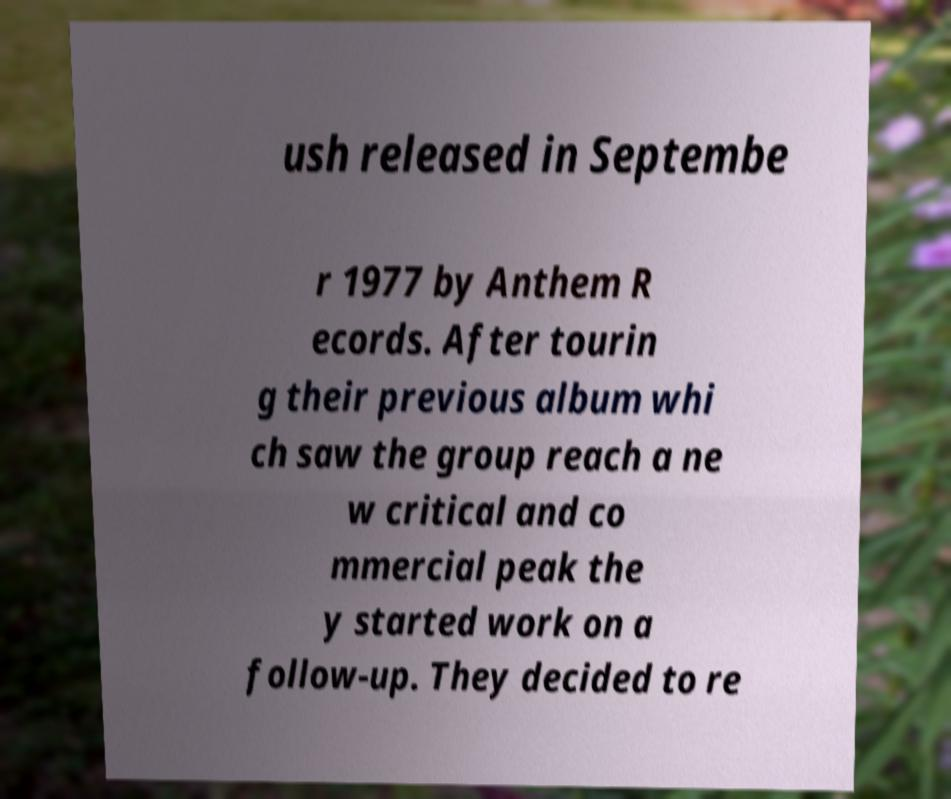Please read and relay the text visible in this image. What does it say? ush released in Septembe r 1977 by Anthem R ecords. After tourin g their previous album whi ch saw the group reach a ne w critical and co mmercial peak the y started work on a follow-up. They decided to re 